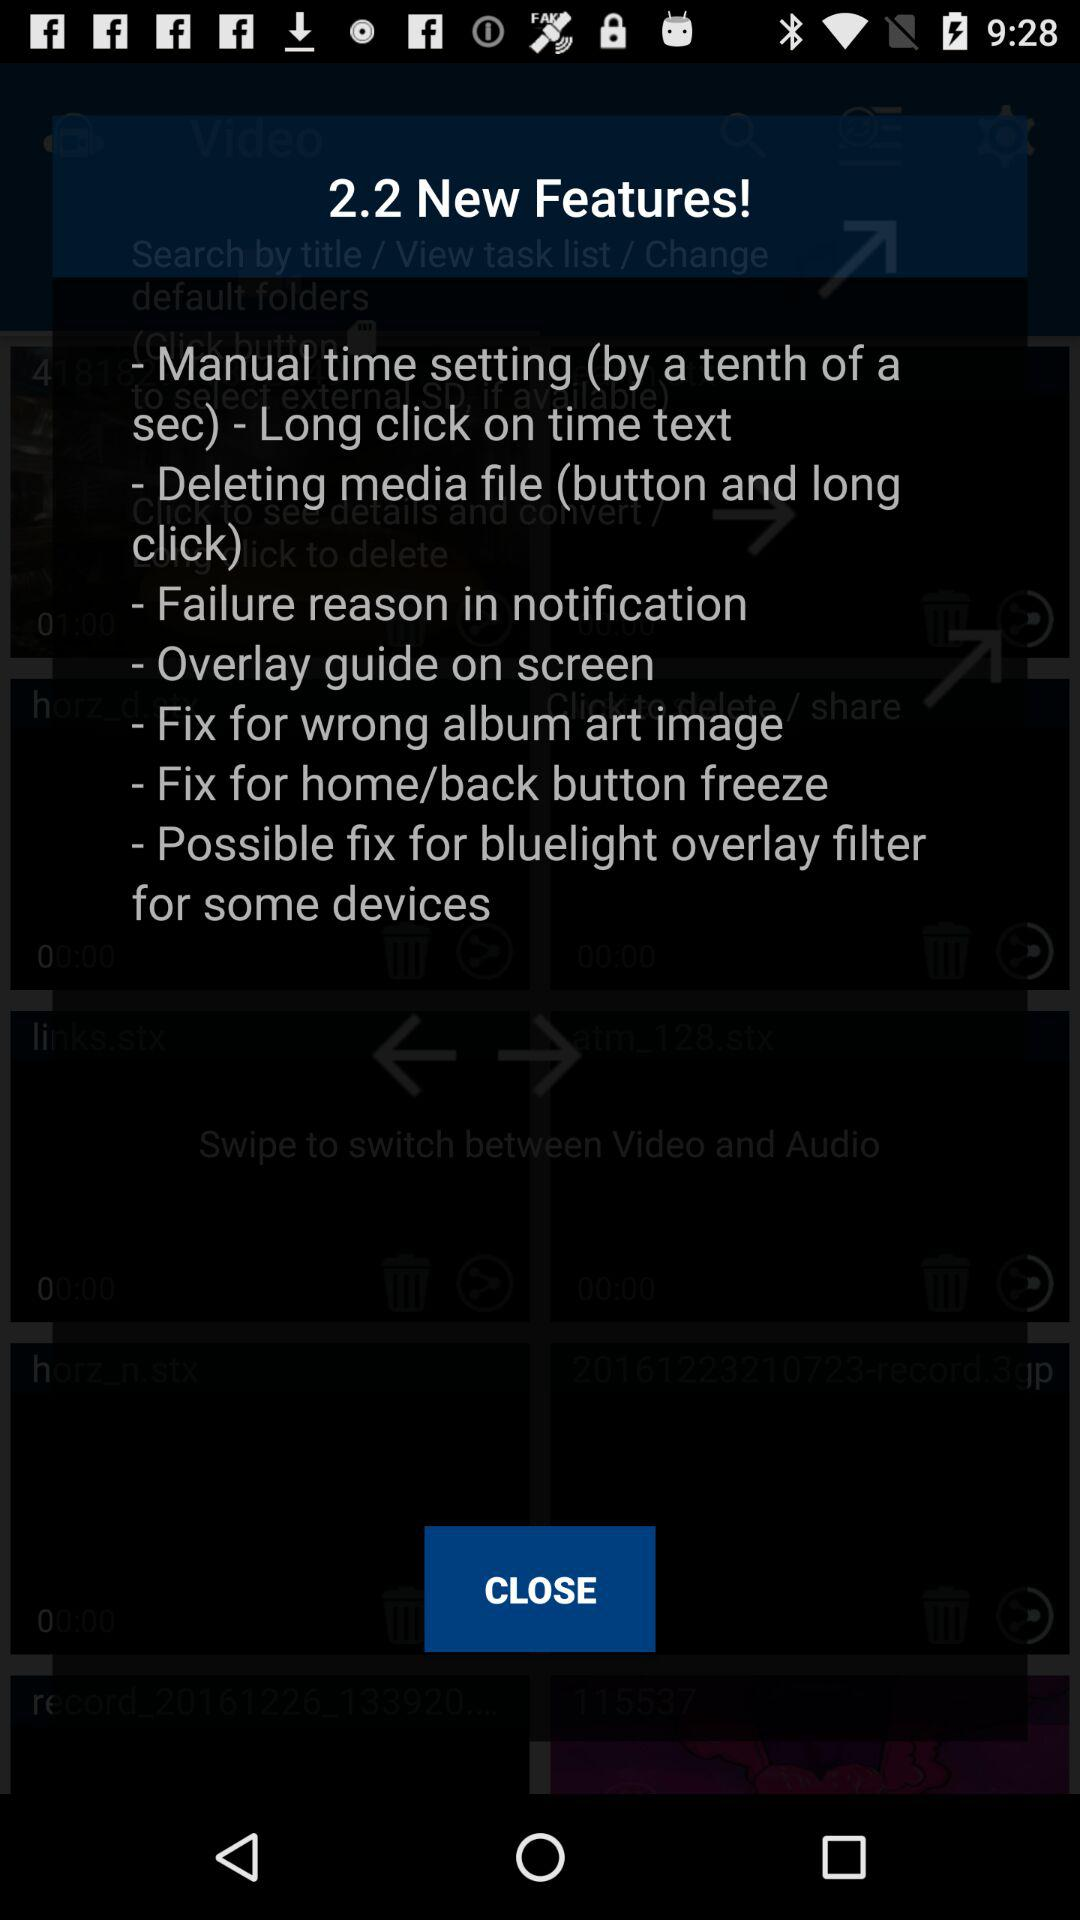What is the version of the new features? The version is 2.2. 